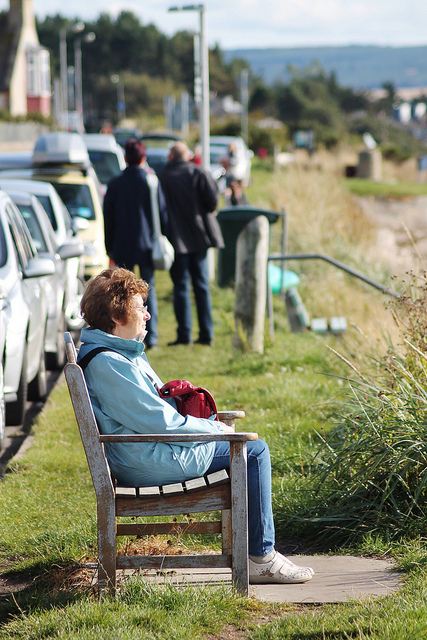<image>What kind of glasses is the woman wearing? I can't be certain what kind of glasses the woman is wearing. It could be reading, prescription or eyeglasses. What kind of glasses is the woman wearing? It is unanswerable what kind of glasses the woman is wearing. 